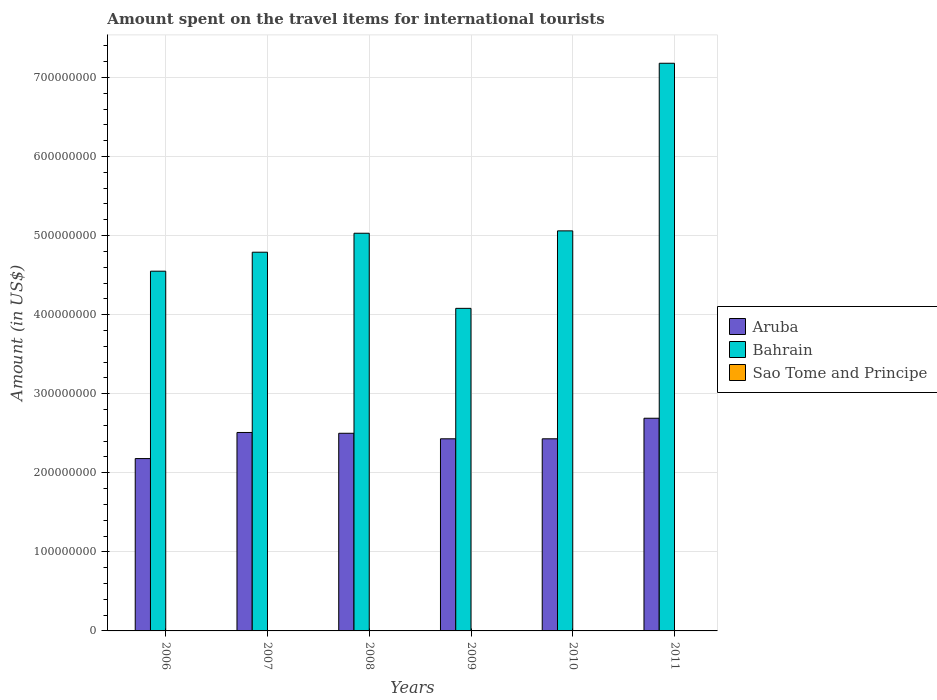How many groups of bars are there?
Make the answer very short. 6. Are the number of bars per tick equal to the number of legend labels?
Provide a short and direct response. Yes. Are the number of bars on each tick of the X-axis equal?
Provide a succinct answer. Yes. How many bars are there on the 4th tick from the left?
Give a very brief answer. 3. How many bars are there on the 1st tick from the right?
Provide a short and direct response. 3. What is the label of the 3rd group of bars from the left?
Give a very brief answer. 2008. In how many cases, is the number of bars for a given year not equal to the number of legend labels?
Offer a terse response. 0. Across all years, what is the maximum amount spent on the travel items for international tourists in Bahrain?
Make the answer very short. 7.18e+08. Across all years, what is the minimum amount spent on the travel items for international tourists in Bahrain?
Your response must be concise. 4.08e+08. In which year was the amount spent on the travel items for international tourists in Sao Tome and Principe maximum?
Your answer should be compact. 2011. What is the total amount spent on the travel items for international tourists in Aruba in the graph?
Your answer should be compact. 1.47e+09. What is the difference between the amount spent on the travel items for international tourists in Aruba in 2006 and that in 2007?
Give a very brief answer. -3.30e+07. What is the difference between the amount spent on the travel items for international tourists in Sao Tome and Principe in 2010 and the amount spent on the travel items for international tourists in Bahrain in 2006?
Provide a short and direct response. -4.55e+08. What is the average amount spent on the travel items for international tourists in Aruba per year?
Ensure brevity in your answer.  2.46e+08. In the year 2008, what is the difference between the amount spent on the travel items for international tourists in Bahrain and amount spent on the travel items for international tourists in Aruba?
Your answer should be very brief. 2.53e+08. What is the ratio of the amount spent on the travel items for international tourists in Aruba in 2006 to that in 2010?
Keep it short and to the point. 0.9. Is the amount spent on the travel items for international tourists in Aruba in 2006 less than that in 2007?
Provide a succinct answer. Yes. What is the difference between the highest and the lowest amount spent on the travel items for international tourists in Bahrain?
Make the answer very short. 3.10e+08. In how many years, is the amount spent on the travel items for international tourists in Bahrain greater than the average amount spent on the travel items for international tourists in Bahrain taken over all years?
Provide a succinct answer. 1. What does the 3rd bar from the left in 2008 represents?
Give a very brief answer. Sao Tome and Principe. What does the 3rd bar from the right in 2010 represents?
Offer a terse response. Aruba. How many bars are there?
Keep it short and to the point. 18. What is the difference between two consecutive major ticks on the Y-axis?
Your response must be concise. 1.00e+08. Are the values on the major ticks of Y-axis written in scientific E-notation?
Your answer should be very brief. No. Does the graph contain grids?
Give a very brief answer. Yes. Where does the legend appear in the graph?
Your response must be concise. Center right. How are the legend labels stacked?
Keep it short and to the point. Vertical. What is the title of the graph?
Ensure brevity in your answer.  Amount spent on the travel items for international tourists. What is the label or title of the X-axis?
Offer a terse response. Years. What is the Amount (in US$) in Aruba in 2006?
Your answer should be very brief. 2.18e+08. What is the Amount (in US$) in Bahrain in 2006?
Offer a terse response. 4.55e+08. What is the Amount (in US$) of Sao Tome and Principe in 2006?
Ensure brevity in your answer.  2.00e+05. What is the Amount (in US$) of Aruba in 2007?
Your answer should be very brief. 2.51e+08. What is the Amount (in US$) of Bahrain in 2007?
Make the answer very short. 4.79e+08. What is the Amount (in US$) in Sao Tome and Principe in 2007?
Your response must be concise. 1.00e+05. What is the Amount (in US$) in Aruba in 2008?
Give a very brief answer. 2.50e+08. What is the Amount (in US$) in Bahrain in 2008?
Offer a terse response. 5.03e+08. What is the Amount (in US$) in Sao Tome and Principe in 2008?
Your answer should be compact. 10000. What is the Amount (in US$) in Aruba in 2009?
Provide a succinct answer. 2.43e+08. What is the Amount (in US$) of Bahrain in 2009?
Provide a succinct answer. 4.08e+08. What is the Amount (in US$) in Sao Tome and Principe in 2009?
Your answer should be very brief. 10000. What is the Amount (in US$) in Aruba in 2010?
Ensure brevity in your answer.  2.43e+08. What is the Amount (in US$) of Bahrain in 2010?
Ensure brevity in your answer.  5.06e+08. What is the Amount (in US$) of Aruba in 2011?
Provide a short and direct response. 2.69e+08. What is the Amount (in US$) of Bahrain in 2011?
Your answer should be compact. 7.18e+08. Across all years, what is the maximum Amount (in US$) in Aruba?
Make the answer very short. 2.69e+08. Across all years, what is the maximum Amount (in US$) in Bahrain?
Your answer should be very brief. 7.18e+08. Across all years, what is the minimum Amount (in US$) of Aruba?
Provide a succinct answer. 2.18e+08. Across all years, what is the minimum Amount (in US$) of Bahrain?
Give a very brief answer. 4.08e+08. Across all years, what is the minimum Amount (in US$) in Sao Tome and Principe?
Offer a terse response. 10000. What is the total Amount (in US$) in Aruba in the graph?
Ensure brevity in your answer.  1.47e+09. What is the total Amount (in US$) of Bahrain in the graph?
Offer a terse response. 3.07e+09. What is the total Amount (in US$) in Sao Tome and Principe in the graph?
Offer a very short reply. 7.20e+05. What is the difference between the Amount (in US$) in Aruba in 2006 and that in 2007?
Offer a very short reply. -3.30e+07. What is the difference between the Amount (in US$) in Bahrain in 2006 and that in 2007?
Keep it short and to the point. -2.40e+07. What is the difference between the Amount (in US$) of Aruba in 2006 and that in 2008?
Offer a very short reply. -3.20e+07. What is the difference between the Amount (in US$) in Bahrain in 2006 and that in 2008?
Your answer should be very brief. -4.80e+07. What is the difference between the Amount (in US$) of Aruba in 2006 and that in 2009?
Offer a very short reply. -2.50e+07. What is the difference between the Amount (in US$) of Bahrain in 2006 and that in 2009?
Your answer should be compact. 4.70e+07. What is the difference between the Amount (in US$) in Sao Tome and Principe in 2006 and that in 2009?
Offer a very short reply. 1.90e+05. What is the difference between the Amount (in US$) of Aruba in 2006 and that in 2010?
Provide a short and direct response. -2.50e+07. What is the difference between the Amount (in US$) of Bahrain in 2006 and that in 2010?
Give a very brief answer. -5.10e+07. What is the difference between the Amount (in US$) in Aruba in 2006 and that in 2011?
Make the answer very short. -5.10e+07. What is the difference between the Amount (in US$) in Bahrain in 2006 and that in 2011?
Your response must be concise. -2.63e+08. What is the difference between the Amount (in US$) of Bahrain in 2007 and that in 2008?
Keep it short and to the point. -2.40e+07. What is the difference between the Amount (in US$) in Sao Tome and Principe in 2007 and that in 2008?
Keep it short and to the point. 9.00e+04. What is the difference between the Amount (in US$) of Aruba in 2007 and that in 2009?
Your answer should be very brief. 8.00e+06. What is the difference between the Amount (in US$) in Bahrain in 2007 and that in 2009?
Give a very brief answer. 7.10e+07. What is the difference between the Amount (in US$) in Sao Tome and Principe in 2007 and that in 2009?
Your response must be concise. 9.00e+04. What is the difference between the Amount (in US$) in Aruba in 2007 and that in 2010?
Keep it short and to the point. 8.00e+06. What is the difference between the Amount (in US$) in Bahrain in 2007 and that in 2010?
Provide a succinct answer. -2.70e+07. What is the difference between the Amount (in US$) in Aruba in 2007 and that in 2011?
Give a very brief answer. -1.80e+07. What is the difference between the Amount (in US$) of Bahrain in 2007 and that in 2011?
Provide a succinct answer. -2.39e+08. What is the difference between the Amount (in US$) in Bahrain in 2008 and that in 2009?
Provide a succinct answer. 9.50e+07. What is the difference between the Amount (in US$) in Bahrain in 2008 and that in 2010?
Keep it short and to the point. -3.00e+06. What is the difference between the Amount (in US$) of Sao Tome and Principe in 2008 and that in 2010?
Offer a terse response. -4.00e+04. What is the difference between the Amount (in US$) in Aruba in 2008 and that in 2011?
Make the answer very short. -1.90e+07. What is the difference between the Amount (in US$) in Bahrain in 2008 and that in 2011?
Your answer should be compact. -2.15e+08. What is the difference between the Amount (in US$) of Sao Tome and Principe in 2008 and that in 2011?
Give a very brief answer. -3.40e+05. What is the difference between the Amount (in US$) of Bahrain in 2009 and that in 2010?
Give a very brief answer. -9.80e+07. What is the difference between the Amount (in US$) of Aruba in 2009 and that in 2011?
Your answer should be very brief. -2.60e+07. What is the difference between the Amount (in US$) in Bahrain in 2009 and that in 2011?
Provide a short and direct response. -3.10e+08. What is the difference between the Amount (in US$) of Sao Tome and Principe in 2009 and that in 2011?
Offer a terse response. -3.40e+05. What is the difference between the Amount (in US$) in Aruba in 2010 and that in 2011?
Your answer should be compact. -2.60e+07. What is the difference between the Amount (in US$) in Bahrain in 2010 and that in 2011?
Your answer should be very brief. -2.12e+08. What is the difference between the Amount (in US$) of Sao Tome and Principe in 2010 and that in 2011?
Offer a terse response. -3.00e+05. What is the difference between the Amount (in US$) in Aruba in 2006 and the Amount (in US$) in Bahrain in 2007?
Offer a terse response. -2.61e+08. What is the difference between the Amount (in US$) of Aruba in 2006 and the Amount (in US$) of Sao Tome and Principe in 2007?
Keep it short and to the point. 2.18e+08. What is the difference between the Amount (in US$) in Bahrain in 2006 and the Amount (in US$) in Sao Tome and Principe in 2007?
Your response must be concise. 4.55e+08. What is the difference between the Amount (in US$) in Aruba in 2006 and the Amount (in US$) in Bahrain in 2008?
Your response must be concise. -2.85e+08. What is the difference between the Amount (in US$) in Aruba in 2006 and the Amount (in US$) in Sao Tome and Principe in 2008?
Your answer should be compact. 2.18e+08. What is the difference between the Amount (in US$) of Bahrain in 2006 and the Amount (in US$) of Sao Tome and Principe in 2008?
Make the answer very short. 4.55e+08. What is the difference between the Amount (in US$) in Aruba in 2006 and the Amount (in US$) in Bahrain in 2009?
Your answer should be very brief. -1.90e+08. What is the difference between the Amount (in US$) of Aruba in 2006 and the Amount (in US$) of Sao Tome and Principe in 2009?
Offer a very short reply. 2.18e+08. What is the difference between the Amount (in US$) in Bahrain in 2006 and the Amount (in US$) in Sao Tome and Principe in 2009?
Ensure brevity in your answer.  4.55e+08. What is the difference between the Amount (in US$) in Aruba in 2006 and the Amount (in US$) in Bahrain in 2010?
Your answer should be compact. -2.88e+08. What is the difference between the Amount (in US$) in Aruba in 2006 and the Amount (in US$) in Sao Tome and Principe in 2010?
Ensure brevity in your answer.  2.18e+08. What is the difference between the Amount (in US$) in Bahrain in 2006 and the Amount (in US$) in Sao Tome and Principe in 2010?
Make the answer very short. 4.55e+08. What is the difference between the Amount (in US$) of Aruba in 2006 and the Amount (in US$) of Bahrain in 2011?
Offer a terse response. -5.00e+08. What is the difference between the Amount (in US$) of Aruba in 2006 and the Amount (in US$) of Sao Tome and Principe in 2011?
Your response must be concise. 2.18e+08. What is the difference between the Amount (in US$) of Bahrain in 2006 and the Amount (in US$) of Sao Tome and Principe in 2011?
Provide a short and direct response. 4.55e+08. What is the difference between the Amount (in US$) in Aruba in 2007 and the Amount (in US$) in Bahrain in 2008?
Give a very brief answer. -2.52e+08. What is the difference between the Amount (in US$) in Aruba in 2007 and the Amount (in US$) in Sao Tome and Principe in 2008?
Provide a short and direct response. 2.51e+08. What is the difference between the Amount (in US$) of Bahrain in 2007 and the Amount (in US$) of Sao Tome and Principe in 2008?
Offer a terse response. 4.79e+08. What is the difference between the Amount (in US$) of Aruba in 2007 and the Amount (in US$) of Bahrain in 2009?
Offer a very short reply. -1.57e+08. What is the difference between the Amount (in US$) in Aruba in 2007 and the Amount (in US$) in Sao Tome and Principe in 2009?
Offer a very short reply. 2.51e+08. What is the difference between the Amount (in US$) in Bahrain in 2007 and the Amount (in US$) in Sao Tome and Principe in 2009?
Offer a terse response. 4.79e+08. What is the difference between the Amount (in US$) of Aruba in 2007 and the Amount (in US$) of Bahrain in 2010?
Offer a very short reply. -2.55e+08. What is the difference between the Amount (in US$) of Aruba in 2007 and the Amount (in US$) of Sao Tome and Principe in 2010?
Provide a short and direct response. 2.51e+08. What is the difference between the Amount (in US$) in Bahrain in 2007 and the Amount (in US$) in Sao Tome and Principe in 2010?
Keep it short and to the point. 4.79e+08. What is the difference between the Amount (in US$) in Aruba in 2007 and the Amount (in US$) in Bahrain in 2011?
Your answer should be very brief. -4.67e+08. What is the difference between the Amount (in US$) of Aruba in 2007 and the Amount (in US$) of Sao Tome and Principe in 2011?
Your response must be concise. 2.51e+08. What is the difference between the Amount (in US$) of Bahrain in 2007 and the Amount (in US$) of Sao Tome and Principe in 2011?
Provide a short and direct response. 4.79e+08. What is the difference between the Amount (in US$) of Aruba in 2008 and the Amount (in US$) of Bahrain in 2009?
Offer a very short reply. -1.58e+08. What is the difference between the Amount (in US$) of Aruba in 2008 and the Amount (in US$) of Sao Tome and Principe in 2009?
Make the answer very short. 2.50e+08. What is the difference between the Amount (in US$) in Bahrain in 2008 and the Amount (in US$) in Sao Tome and Principe in 2009?
Provide a succinct answer. 5.03e+08. What is the difference between the Amount (in US$) of Aruba in 2008 and the Amount (in US$) of Bahrain in 2010?
Your answer should be compact. -2.56e+08. What is the difference between the Amount (in US$) in Aruba in 2008 and the Amount (in US$) in Sao Tome and Principe in 2010?
Provide a short and direct response. 2.50e+08. What is the difference between the Amount (in US$) in Bahrain in 2008 and the Amount (in US$) in Sao Tome and Principe in 2010?
Your answer should be very brief. 5.03e+08. What is the difference between the Amount (in US$) in Aruba in 2008 and the Amount (in US$) in Bahrain in 2011?
Offer a terse response. -4.68e+08. What is the difference between the Amount (in US$) of Aruba in 2008 and the Amount (in US$) of Sao Tome and Principe in 2011?
Your answer should be very brief. 2.50e+08. What is the difference between the Amount (in US$) of Bahrain in 2008 and the Amount (in US$) of Sao Tome and Principe in 2011?
Your answer should be very brief. 5.03e+08. What is the difference between the Amount (in US$) of Aruba in 2009 and the Amount (in US$) of Bahrain in 2010?
Give a very brief answer. -2.63e+08. What is the difference between the Amount (in US$) of Aruba in 2009 and the Amount (in US$) of Sao Tome and Principe in 2010?
Provide a short and direct response. 2.43e+08. What is the difference between the Amount (in US$) in Bahrain in 2009 and the Amount (in US$) in Sao Tome and Principe in 2010?
Give a very brief answer. 4.08e+08. What is the difference between the Amount (in US$) in Aruba in 2009 and the Amount (in US$) in Bahrain in 2011?
Your answer should be compact. -4.75e+08. What is the difference between the Amount (in US$) in Aruba in 2009 and the Amount (in US$) in Sao Tome and Principe in 2011?
Provide a succinct answer. 2.43e+08. What is the difference between the Amount (in US$) in Bahrain in 2009 and the Amount (in US$) in Sao Tome and Principe in 2011?
Your response must be concise. 4.08e+08. What is the difference between the Amount (in US$) of Aruba in 2010 and the Amount (in US$) of Bahrain in 2011?
Your answer should be very brief. -4.75e+08. What is the difference between the Amount (in US$) in Aruba in 2010 and the Amount (in US$) in Sao Tome and Principe in 2011?
Provide a succinct answer. 2.43e+08. What is the difference between the Amount (in US$) in Bahrain in 2010 and the Amount (in US$) in Sao Tome and Principe in 2011?
Your response must be concise. 5.06e+08. What is the average Amount (in US$) in Aruba per year?
Give a very brief answer. 2.46e+08. What is the average Amount (in US$) of Bahrain per year?
Make the answer very short. 5.12e+08. In the year 2006, what is the difference between the Amount (in US$) in Aruba and Amount (in US$) in Bahrain?
Offer a terse response. -2.37e+08. In the year 2006, what is the difference between the Amount (in US$) of Aruba and Amount (in US$) of Sao Tome and Principe?
Your response must be concise. 2.18e+08. In the year 2006, what is the difference between the Amount (in US$) of Bahrain and Amount (in US$) of Sao Tome and Principe?
Make the answer very short. 4.55e+08. In the year 2007, what is the difference between the Amount (in US$) of Aruba and Amount (in US$) of Bahrain?
Offer a very short reply. -2.28e+08. In the year 2007, what is the difference between the Amount (in US$) of Aruba and Amount (in US$) of Sao Tome and Principe?
Your answer should be compact. 2.51e+08. In the year 2007, what is the difference between the Amount (in US$) of Bahrain and Amount (in US$) of Sao Tome and Principe?
Keep it short and to the point. 4.79e+08. In the year 2008, what is the difference between the Amount (in US$) of Aruba and Amount (in US$) of Bahrain?
Your answer should be very brief. -2.53e+08. In the year 2008, what is the difference between the Amount (in US$) in Aruba and Amount (in US$) in Sao Tome and Principe?
Ensure brevity in your answer.  2.50e+08. In the year 2008, what is the difference between the Amount (in US$) in Bahrain and Amount (in US$) in Sao Tome and Principe?
Keep it short and to the point. 5.03e+08. In the year 2009, what is the difference between the Amount (in US$) in Aruba and Amount (in US$) in Bahrain?
Provide a short and direct response. -1.65e+08. In the year 2009, what is the difference between the Amount (in US$) in Aruba and Amount (in US$) in Sao Tome and Principe?
Your answer should be very brief. 2.43e+08. In the year 2009, what is the difference between the Amount (in US$) of Bahrain and Amount (in US$) of Sao Tome and Principe?
Your answer should be compact. 4.08e+08. In the year 2010, what is the difference between the Amount (in US$) in Aruba and Amount (in US$) in Bahrain?
Make the answer very short. -2.63e+08. In the year 2010, what is the difference between the Amount (in US$) in Aruba and Amount (in US$) in Sao Tome and Principe?
Your answer should be very brief. 2.43e+08. In the year 2010, what is the difference between the Amount (in US$) in Bahrain and Amount (in US$) in Sao Tome and Principe?
Your answer should be compact. 5.06e+08. In the year 2011, what is the difference between the Amount (in US$) in Aruba and Amount (in US$) in Bahrain?
Make the answer very short. -4.49e+08. In the year 2011, what is the difference between the Amount (in US$) in Aruba and Amount (in US$) in Sao Tome and Principe?
Your response must be concise. 2.69e+08. In the year 2011, what is the difference between the Amount (in US$) of Bahrain and Amount (in US$) of Sao Tome and Principe?
Make the answer very short. 7.18e+08. What is the ratio of the Amount (in US$) in Aruba in 2006 to that in 2007?
Your response must be concise. 0.87. What is the ratio of the Amount (in US$) in Bahrain in 2006 to that in 2007?
Offer a terse response. 0.95. What is the ratio of the Amount (in US$) in Sao Tome and Principe in 2006 to that in 2007?
Give a very brief answer. 2. What is the ratio of the Amount (in US$) of Aruba in 2006 to that in 2008?
Offer a very short reply. 0.87. What is the ratio of the Amount (in US$) of Bahrain in 2006 to that in 2008?
Your answer should be compact. 0.9. What is the ratio of the Amount (in US$) in Aruba in 2006 to that in 2009?
Offer a very short reply. 0.9. What is the ratio of the Amount (in US$) of Bahrain in 2006 to that in 2009?
Your answer should be compact. 1.12. What is the ratio of the Amount (in US$) in Aruba in 2006 to that in 2010?
Your response must be concise. 0.9. What is the ratio of the Amount (in US$) in Bahrain in 2006 to that in 2010?
Offer a terse response. 0.9. What is the ratio of the Amount (in US$) in Aruba in 2006 to that in 2011?
Offer a terse response. 0.81. What is the ratio of the Amount (in US$) in Bahrain in 2006 to that in 2011?
Your answer should be very brief. 0.63. What is the ratio of the Amount (in US$) of Bahrain in 2007 to that in 2008?
Offer a very short reply. 0.95. What is the ratio of the Amount (in US$) in Aruba in 2007 to that in 2009?
Make the answer very short. 1.03. What is the ratio of the Amount (in US$) in Bahrain in 2007 to that in 2009?
Offer a terse response. 1.17. What is the ratio of the Amount (in US$) in Sao Tome and Principe in 2007 to that in 2009?
Make the answer very short. 10. What is the ratio of the Amount (in US$) in Aruba in 2007 to that in 2010?
Keep it short and to the point. 1.03. What is the ratio of the Amount (in US$) of Bahrain in 2007 to that in 2010?
Offer a very short reply. 0.95. What is the ratio of the Amount (in US$) of Aruba in 2007 to that in 2011?
Make the answer very short. 0.93. What is the ratio of the Amount (in US$) of Bahrain in 2007 to that in 2011?
Provide a short and direct response. 0.67. What is the ratio of the Amount (in US$) of Sao Tome and Principe in 2007 to that in 2011?
Offer a terse response. 0.29. What is the ratio of the Amount (in US$) in Aruba in 2008 to that in 2009?
Make the answer very short. 1.03. What is the ratio of the Amount (in US$) in Bahrain in 2008 to that in 2009?
Offer a very short reply. 1.23. What is the ratio of the Amount (in US$) in Sao Tome and Principe in 2008 to that in 2009?
Keep it short and to the point. 1. What is the ratio of the Amount (in US$) of Aruba in 2008 to that in 2010?
Give a very brief answer. 1.03. What is the ratio of the Amount (in US$) in Aruba in 2008 to that in 2011?
Your response must be concise. 0.93. What is the ratio of the Amount (in US$) in Bahrain in 2008 to that in 2011?
Provide a succinct answer. 0.7. What is the ratio of the Amount (in US$) in Sao Tome and Principe in 2008 to that in 2011?
Your answer should be very brief. 0.03. What is the ratio of the Amount (in US$) of Aruba in 2009 to that in 2010?
Offer a very short reply. 1. What is the ratio of the Amount (in US$) in Bahrain in 2009 to that in 2010?
Your response must be concise. 0.81. What is the ratio of the Amount (in US$) of Aruba in 2009 to that in 2011?
Provide a succinct answer. 0.9. What is the ratio of the Amount (in US$) in Bahrain in 2009 to that in 2011?
Your answer should be very brief. 0.57. What is the ratio of the Amount (in US$) of Sao Tome and Principe in 2009 to that in 2011?
Ensure brevity in your answer.  0.03. What is the ratio of the Amount (in US$) of Aruba in 2010 to that in 2011?
Your response must be concise. 0.9. What is the ratio of the Amount (in US$) in Bahrain in 2010 to that in 2011?
Ensure brevity in your answer.  0.7. What is the ratio of the Amount (in US$) in Sao Tome and Principe in 2010 to that in 2011?
Provide a succinct answer. 0.14. What is the difference between the highest and the second highest Amount (in US$) in Aruba?
Provide a succinct answer. 1.80e+07. What is the difference between the highest and the second highest Amount (in US$) of Bahrain?
Your answer should be very brief. 2.12e+08. What is the difference between the highest and the second highest Amount (in US$) of Sao Tome and Principe?
Your response must be concise. 1.50e+05. What is the difference between the highest and the lowest Amount (in US$) in Aruba?
Provide a short and direct response. 5.10e+07. What is the difference between the highest and the lowest Amount (in US$) in Bahrain?
Keep it short and to the point. 3.10e+08. 